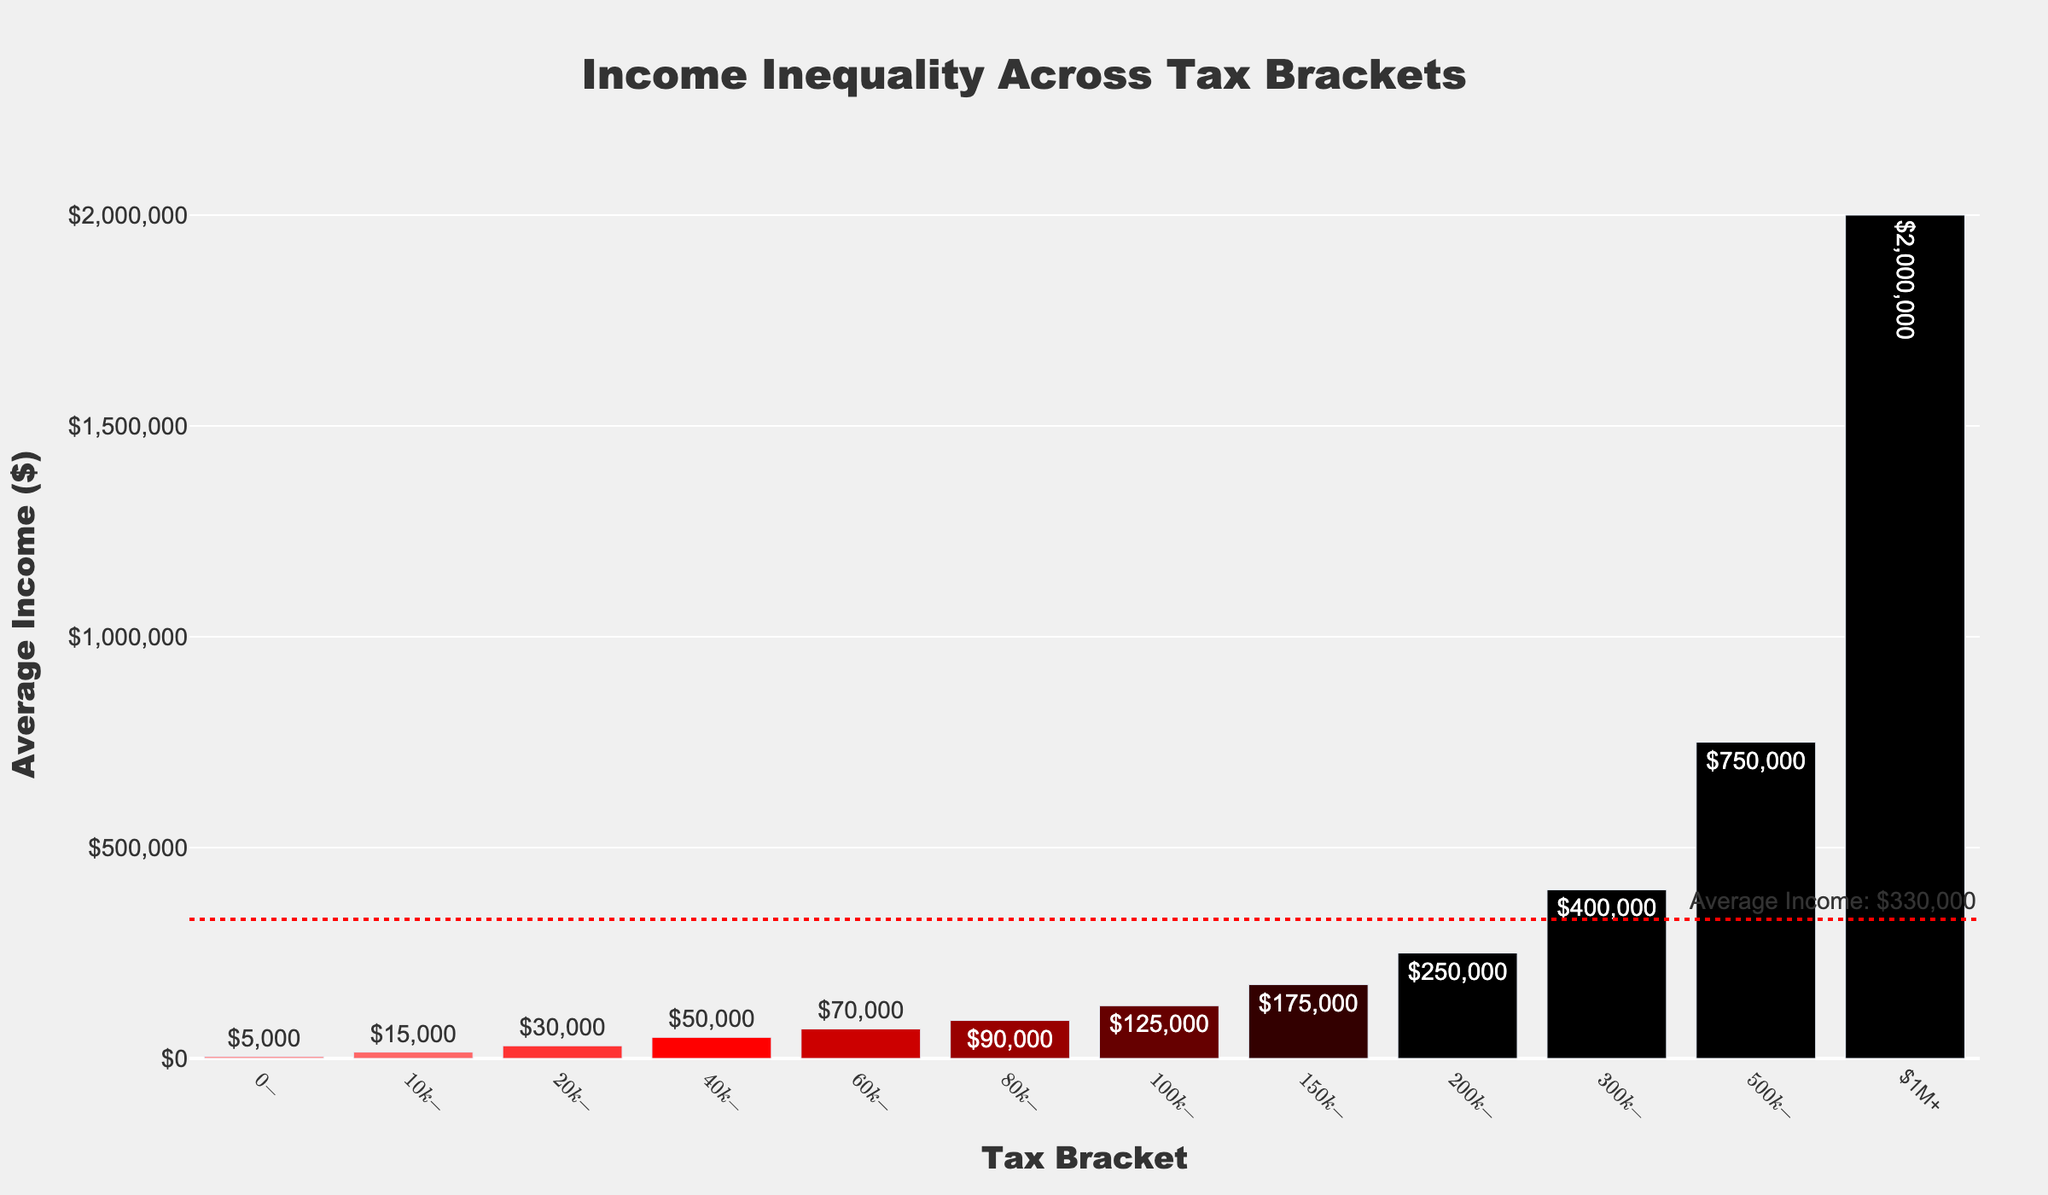What is the average income for the $300k-$500k tax bracket? The bar for the $300k-$500k tax bracket shows an average income of $400,000.
Answer: $400,000 Which tax bracket has the highest effective tax rate? The hovertext for each bar provides the effective tax rate. The $1M+ bracket shows the highest rate at 39.6%.
Answer: $1M+ How much higher is the average income for the $500k-$1M bracket compared to the $200k-$300k bracket? The average income for the $500k-$1M bracket is $750,000 and $250,000 for the $200k-$300k bracket. The difference is $750,000 - $250,000 = $500,000.
Answer: $500,000 What is the effective tax rate for the $60k-$80k bracket? The hovertext for the $60k-$80k bracket bar indicates an effective tax rate of 17.0%.
Answer: 17.0% Which tax bracket has the lowest average income? The bar for the $0-$10k tax bracket shows the lowest average income at $5,000.
Answer: $0-$10k How does the average income of the $80k-$100k bracket compare to the average income across all brackets? The average income across all brackets is shown by the red dotted line. The $80k-$100k bracket's average income is $90,000 which appears to be above the line, suggesting it is higher than the overall average.
Answer: Higher What is the sum of the average incomes for the $40k-$60k and $60k-$80k brackets? The average income for $40k-$60k is $50,000 and for $60k-$80k is $70,000. The sum is $50,000 + $70,000 = $120,000.
Answer: $120,000 Which tax bracket's bar is directly above the red dotted line representing the average income across all brackets? The $80k-$100k bracket's bar is positioned directly above the red dotted line, indicating its average income is close to but above the average across all brackets.
Answer: $80k-$100k What is the difference in effective tax rate between the $200k-$300k and $100k-$150k brackets? The hovertext shows an effective tax rate of 31.0% for the $200k-$300k bracket and 24.0% for the $100k-$150k bracket. The difference is 31.0% - 24.0% = 7.0%.
Answer: 7.0% Is the effective tax rate for the $10k-$20k bracket greater than the effective tax rate for the $20k-$40k bracket? The hovertext shows the effective tax rate for the $10k-$20k bracket is 2.5% and for the $20k-$40k bracket is 7.0%. 2.5% is less than 7.0%.
Answer: No 